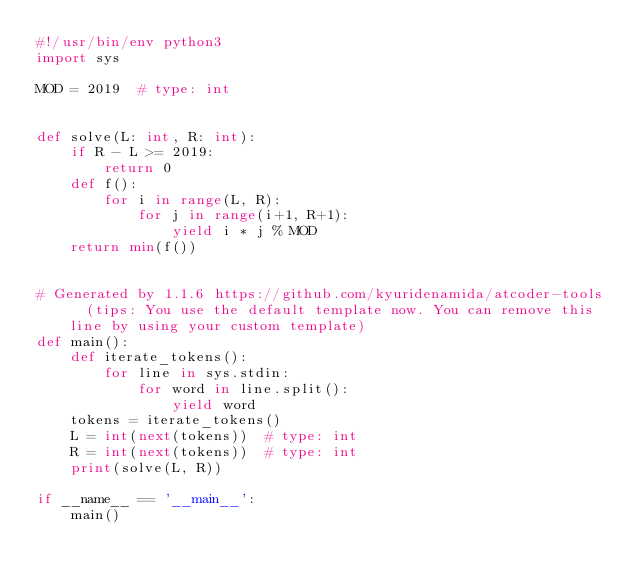<code> <loc_0><loc_0><loc_500><loc_500><_Python_>#!/usr/bin/env python3
import sys

MOD = 2019  # type: int


def solve(L: int, R: int):
    if R - L >= 2019:
        return 0
    def f():
        for i in range(L, R):
            for j in range(i+1, R+1):
                yield i * j % MOD
    return min(f())


# Generated by 1.1.6 https://github.com/kyuridenamida/atcoder-tools  (tips: You use the default template now. You can remove this line by using your custom template)
def main():
    def iterate_tokens():
        for line in sys.stdin:
            for word in line.split():
                yield word
    tokens = iterate_tokens()
    L = int(next(tokens))  # type: int
    R = int(next(tokens))  # type: int
    print(solve(L, R))

if __name__ == '__main__':
    main()
</code> 